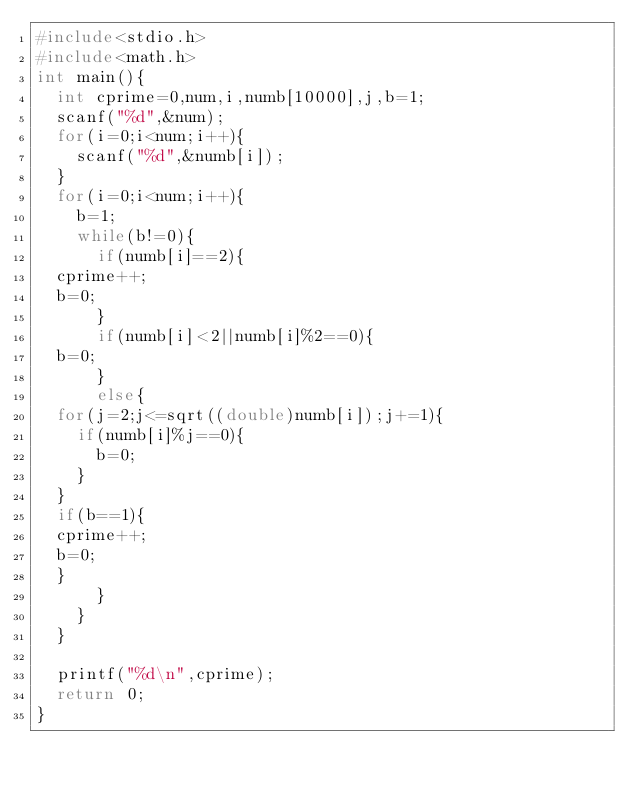<code> <loc_0><loc_0><loc_500><loc_500><_C_>#include<stdio.h>
#include<math.h>
int main(){
  int cprime=0,num,i,numb[10000],j,b=1;
  scanf("%d",&num);
  for(i=0;i<num;i++){
    scanf("%d",&numb[i]);
  }
  for(i=0;i<num;i++){
    b=1;
    while(b!=0){
      if(numb[i]==2){
	cprime++;
	b=0;
      }
      if(numb[i]<2||numb[i]%2==0){
	b=0;
      }
      else{
	for(j=2;j<=sqrt((double)numb[i]);j+=1){
	  if(numb[i]%j==0){
	    b=0;
	  }
	}
	if(b==1){
	cprime++;
	b=0;
	}
      }
    }
  }

  printf("%d\n",cprime);
  return 0;
}</code> 